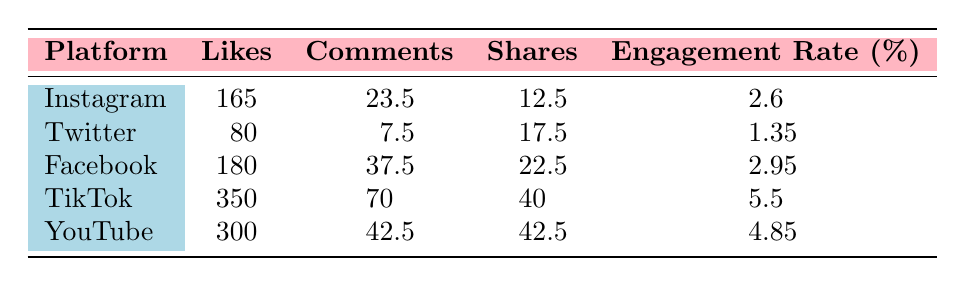What is the platform with the highest average engagement rate? To find the platform with the highest average engagement rate, compare the engagement rates across all platforms listed. TikTok has the highest engagement rate at 5.5%.
Answer: TikTok What is the total number of likes across all posts on YouTube? From the table, YouTube posts have 350 and 300 likes. Adding them gives 350 + 300 = 650 likes in total.
Answer: 650 Is the average number of comments on Facebook posts greater than on Twitter posts? Facebook has an average of 37.5 comments while Twitter has 7.5 comments. Since 37.5 is greater than 7.5, the statement is true.
Answer: Yes Which platform has the least number of shares? Checking the shares across all platforms, Twitter has the least number with an average of 17.5 shares.
Answer: Twitter What is the average number of likes across all platforms listed? The total likes are 165 (Instagram) + 80 (Twitter) + 180 (Facebook) + 350 (TikTok) + 300 (YouTube) = 1075 likes. There are 5 platforms, so the average is 1075 / 5 = 215 likes.
Answer: 215 Does Facebook have a higher engagement rate than Instagram? Facebook's engagement rate is 2.95% while Instagram's is 2.6%. Since 2.95% is greater than 2.6%, Facebook does have a higher engagement rate.
Answer: Yes What is the range of the number of shares across the platforms? The highest number of shares is 42.5 (YouTube), and the lowest is 17.5 (Twitter). The range is calculated as 42.5 - 17.5 = 25.
Answer: 25 How many platforms have an engagement rate above 4%? The platforms with an engagement rate above 4% are TikTok (5.5%) and YouTube (4.85%). There are 2 such platforms.
Answer: 2 What are the average comments for Instagram posts? The average number of comments for Instagram posts is calculated by averaging 23.5 comments from the two Instagram posts. Therefore, the average is 23.5.
Answer: 23.5 